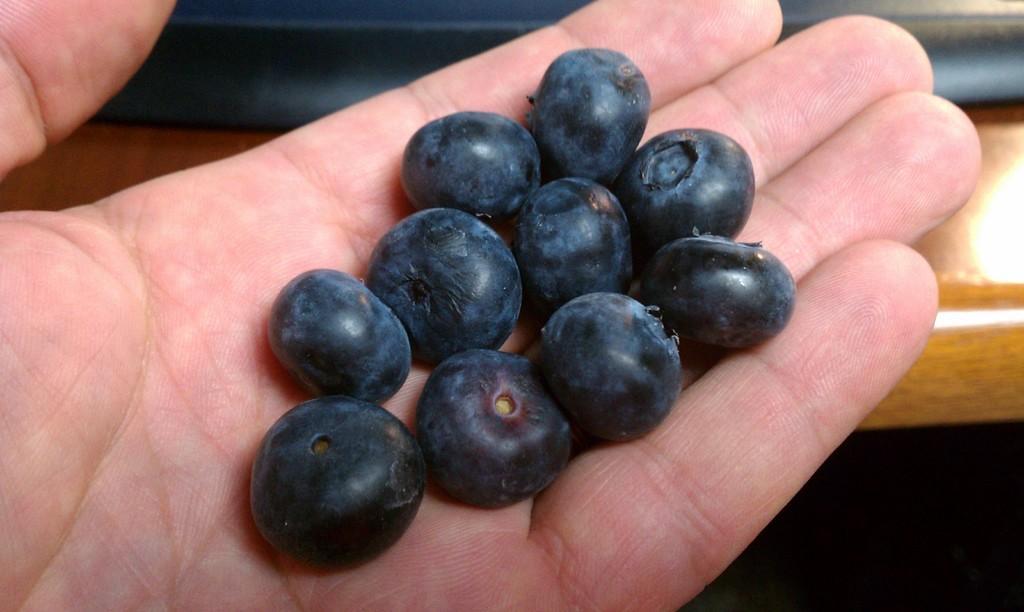How would you summarize this image in a sentence or two? The picture consists of a person hand, in his hand there are blueberries. In the center there is a wooden object. 